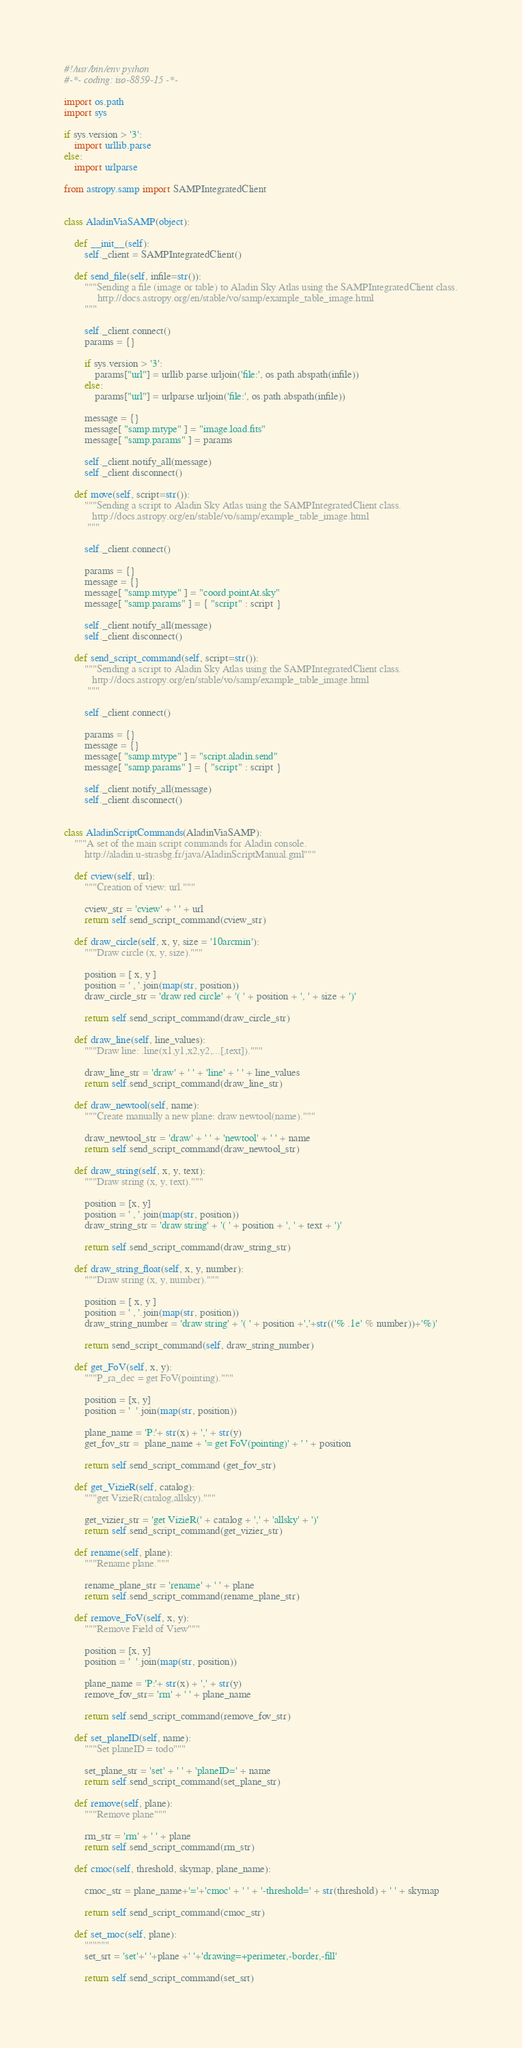Convert code to text. <code><loc_0><loc_0><loc_500><loc_500><_Python_>#!/usr/bin/env python
#-*- coding: iso-8859-15 -*-

import os.path
import sys

if sys.version > '3':
    import urllib.parse
else:
    import urlparse

from astropy.samp import SAMPIntegratedClient


class AladinViaSAMP(object):

    def __init__(self):
        self._client = SAMPIntegratedClient()
        
    def send_file(self, infile=str()):
        """Sending a file (image or table) to Aladin Sky Atlas using the SAMPIntegratedClient class.
             http://docs.astropy.org/en/stable/vo/samp/example_table_image.html
        """   
     
        self._client.connect()
        params = {}

        if sys.version > '3':
            params["url"] = urllib.parse.urljoin('file:', os.path.abspath(infile))
        else:
            params["url"] = urlparse.urljoin('file:', os.path.abspath(infile))
            
        message = {}
        message[ "samp.mtype" ] = "image.load.fits"
        message[ "samp.params" ] = params
     
        self._client.notify_all(message)
        self._client.disconnect()

    def move(self, script=str()):
        """Sending a script to Aladin Sky Atlas using the SAMPIntegratedClient class.
           http://docs.astropy.org/en/stable/vo/samp/example_table_image.html
         """

        self._client.connect()

        params = {}
        message = {} 
        message[ "samp.mtype" ] = "coord.pointAt.sky"
        message[ "samp.params" ] = { "script" : script }  

        self._client.notify_all(message)
        self._client.disconnect()

    def send_script_command(self, script=str()):
        """Sending a script to Aladin Sky Atlas using the SAMPIntegratedClient class.
           http://docs.astropy.org/en/stable/vo/samp/example_table_image.html
         """

        self._client.connect()

        params = {}
        message = {} 
        message[ "samp.mtype" ] = "script.aladin.send"
        message[ "samp.params" ] = { "script" : script }  

        self._client.notify_all(message)
        self._client.disconnect()


class AladinScriptCommands(AladinViaSAMP):
    """A set of the main script commands for Aladin console.
        http://aladin.u-strasbg.fr/java/AladinScriptManual.gml"""

    def cview(self, url):
        """Creation of view: url."""
    
        cview_str = 'cview' + ' ' + url     
        return self.send_script_command(cview_str)

    def draw_circle(self, x, y, size = '10arcmin'):
        """Draw circle (x, y, size)."""
     
        position = [ x, y ]
        position = ' , '.join(map(str, position))  
        draw_circle_str = 'draw red circle' + '( ' + position + ', ' + size + ')'

        return self.send_script_command(draw_circle_str)

    def draw_line(self, line_values):
        """Draw line: .line(x1,y1,x2,y2,...[,text])."""
    
        draw_line_str = 'draw' + ' ' + 'line' + ' ' + line_values   
        return self.send_script_command(draw_line_str)

    def draw_newtool(self, name):
        """Create manually a new plane: draw newtool(name)."""
    
        draw_newtool_str = 'draw' + ' ' + 'newtool' + ' ' + name    
        return self.send_script_command(draw_newtool_str)

    def draw_string(self, x, y, text):
        """Draw string (x, y, text)."""

        position = [x, y]
        position = ' , '.join(map(str, position))
        draw_string_str = 'draw string' + '( ' + position + ', ' + text + ')'

        return self.send_script_command(draw_string_str)

    def draw_string_float(self, x, y, number):
        """Draw string (x, y, number)."""
     
        position = [ x, y ]
        position = ' , '.join(map(str, position))  
        draw_string_number = 'draw string' + '( ' + position +','+str(('% .1e' % number))+'%)'
     
        return send_script_command(self, draw_string_number)

    def get_FoV(self, x, y):
        """P_ra_dec = get FoV(pointing)."""
     
        position = [x, y] 
        position = '  '.join(map(str, position))

        plane_name = 'P:'+ str(x) + ',' + str(y) 
        get_fov_str =  plane_name + '= get FoV(pointing)' + ' ' + position

        return self.send_script_command (get_fov_str)

    def get_VizieR(self, catalog):
        """get VizieR(catalog,allsky)."""  
     
        get_vizier_str = 'get VizieR(' + catalog + ',' + 'allsky' + ')' 
        return self.send_script_command(get_vizier_str)

    def rename(self, plane):
        """Rename plane."""
        
        rename_plane_str = 'rename' + ' ' + plane      
        return self.send_script_command(rename_plane_str)

    def remove_FoV(self, x, y):
        """Remove Field of View"""

        position = [x, y]
        position = '  '.join(map(str, position))
        
        plane_name = 'P:'+ str(x) + ',' + str(y)
        remove_fov_str= 'rm' + ' ' + plane_name

        return self.send_script_command(remove_fov_str)

    def set_planeID(self, name):
        """Set planeID = todo"""

        set_plane_str = 'set' + ' ' + 'planeID=' + name
        return self.send_script_command(set_plane_str)

    def remove(self, plane):
        """Remove plane"""

        rm_str = 'rm' + ' ' + plane
        return self.send_script_command(rm_str)

    def cmoc(self, threshold, skymap, plane_name):

        cmoc_str = plane_name+'='+'cmoc' + ' ' + '-threshold=' + str(threshold) + ' ' + skymap
          
        return self.send_script_command(cmoc_str)

    def set_moc(self, plane):
        """"""
        set_srt = 'set'+' '+plane +' '+'drawing=+perimeter,-border,-fill'

        return self.send_script_command(set_srt)
</code> 